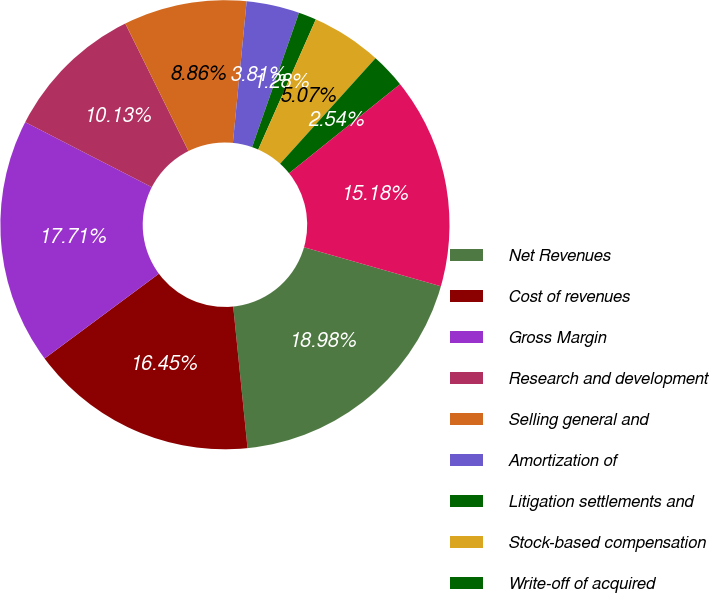<chart> <loc_0><loc_0><loc_500><loc_500><pie_chart><fcel>Net Revenues<fcel>Cost of revenues<fcel>Gross Margin<fcel>Research and development<fcel>Selling general and<fcel>Amortization of<fcel>Litigation settlements and<fcel>Stock-based compensation<fcel>Write-off of acquired<fcel>Total operating expenses<nl><fcel>18.98%<fcel>16.45%<fcel>17.71%<fcel>10.13%<fcel>8.86%<fcel>3.81%<fcel>1.28%<fcel>5.07%<fcel>2.54%<fcel>15.18%<nl></chart> 